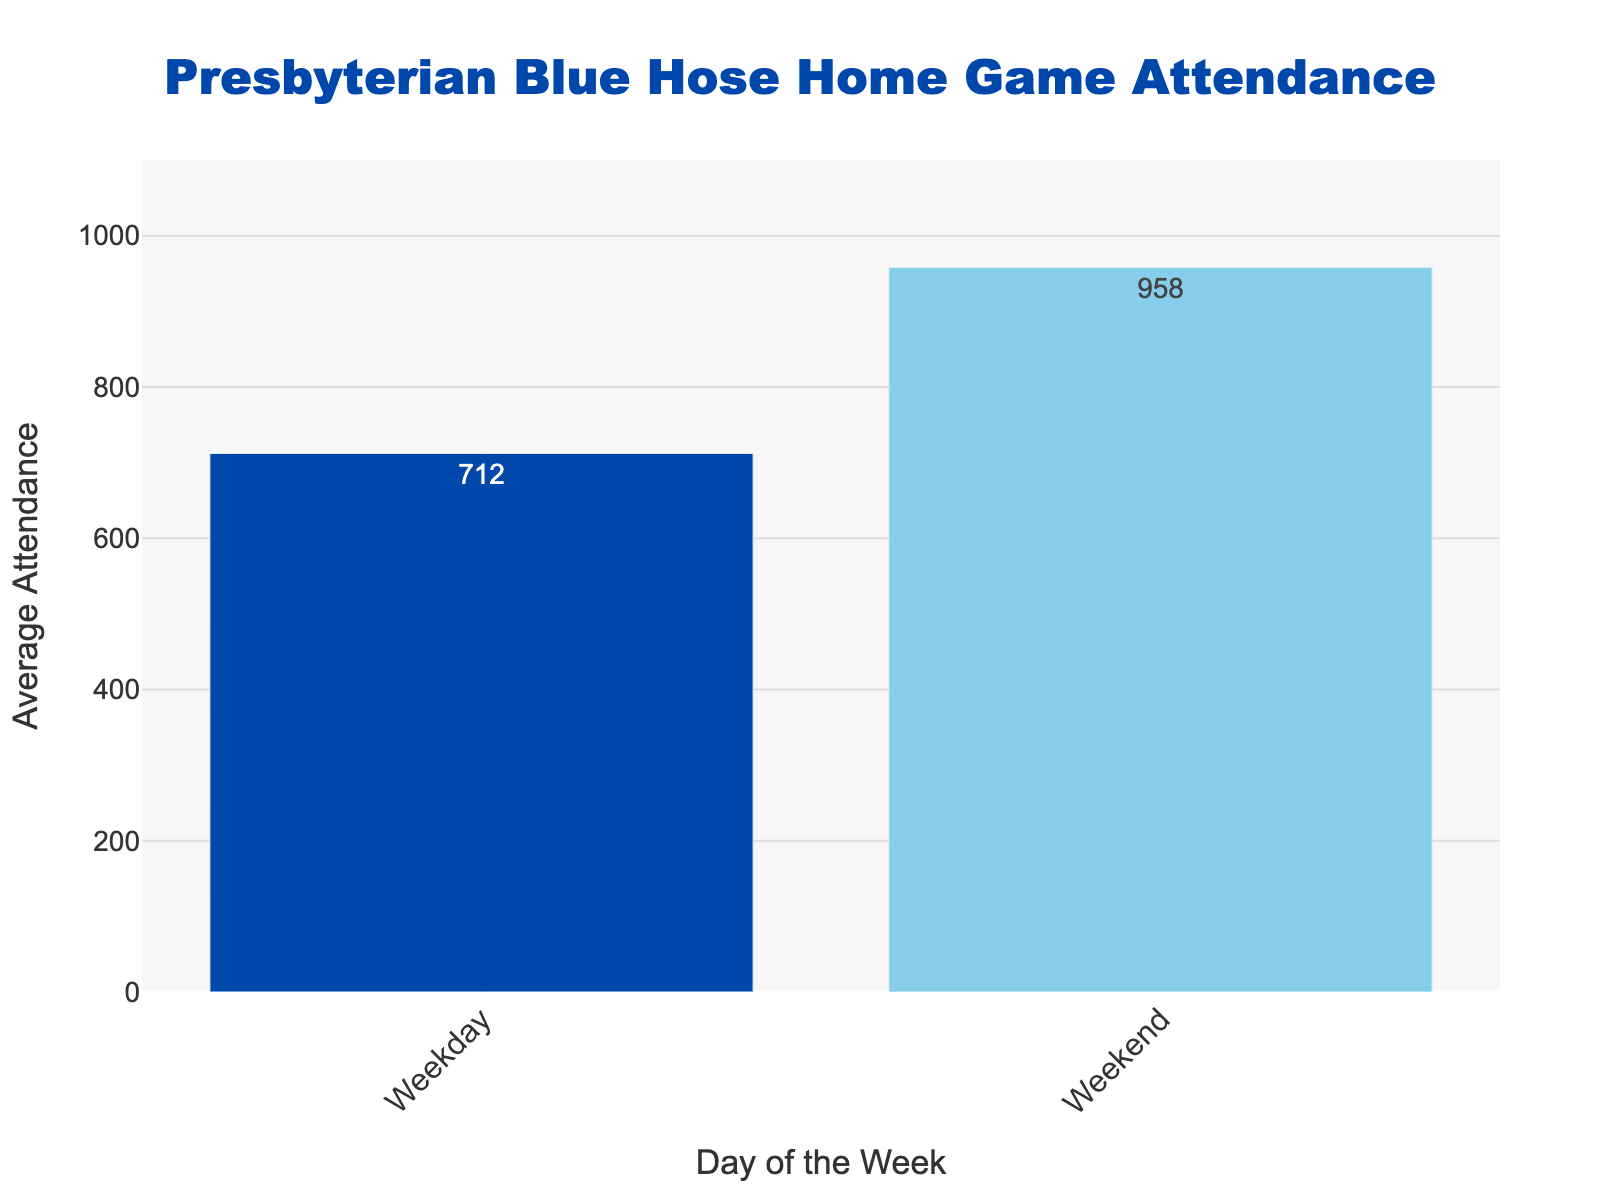What is the difference in average attendance between weekday and weekend home games? To find the difference in average attendance between weekday and weekend games, subtract the average attendance of weekday games (712) from that of weekend games (958). 958 - 712 = 246. So, the difference is 246.
Answer: 246 Which day has a higher average attendance for home games, weekday or weekend? By comparing the heights of the bars, the weekend bar is taller than the weekday bar, indicating higher average attendance on weekends (958) compared to weekdays (712).
Answer: Weekend How much higher is the weekend average attendance compared to weekday games? To determine how much higher the weekend attendance is compared to weekdays, subtract the weekday average (712) from the weekend average (958). The increase is 958 - 712 = 246.
Answer: 246 What is the combined average attendance for both weekdays and weekends? To find the total average attendance, add the weekday average attendance (712) and the weekend average attendance (958). 712 + 958 = 1670.
Answer: 1670 What is the average difference in attendance per day between weekday and weekend games? To calculate the average difference per day, first find the total difference in average attendance (246). The average difference between two data points is the total difference divided by the number of days involved, 246 / 2 = 123.
Answer: 123 Based on the colors used in the bars, what are the two shades represented, and which corresponds to weekday and weekend games? The bar color for weekdays is a darker shade of blue, while the bar color for weekends is a lighter, sky blue shade. Therefore, the darker blue corresponds to weekdays and lighter blue to weekends.
Answer: Weekday: Dark Blue, Weekend: Light Blue Which day experiences lower attendance for home games? By looking at the shorter bar, it is evident that weekdays have a lower average attendance (712) compared to weekends (958).
Answer: Weekdays If the attendance of weekday games were to increase by 100, what would the new weekday average attendance be? To find the new weekday average, add 100 to the current weekday average attendance (712). 712 + 100 = 812.
Answer: 812 If we were to decrease the weekend attendance by 10%, what would the new average attendance for weekends be? To find 10% of the weekend average (958), multiply 958 by 0.10, which equals 95.8. Subtract this from the weekend average: 958 - 95.8 = 862.2.
Answer: 862.2 